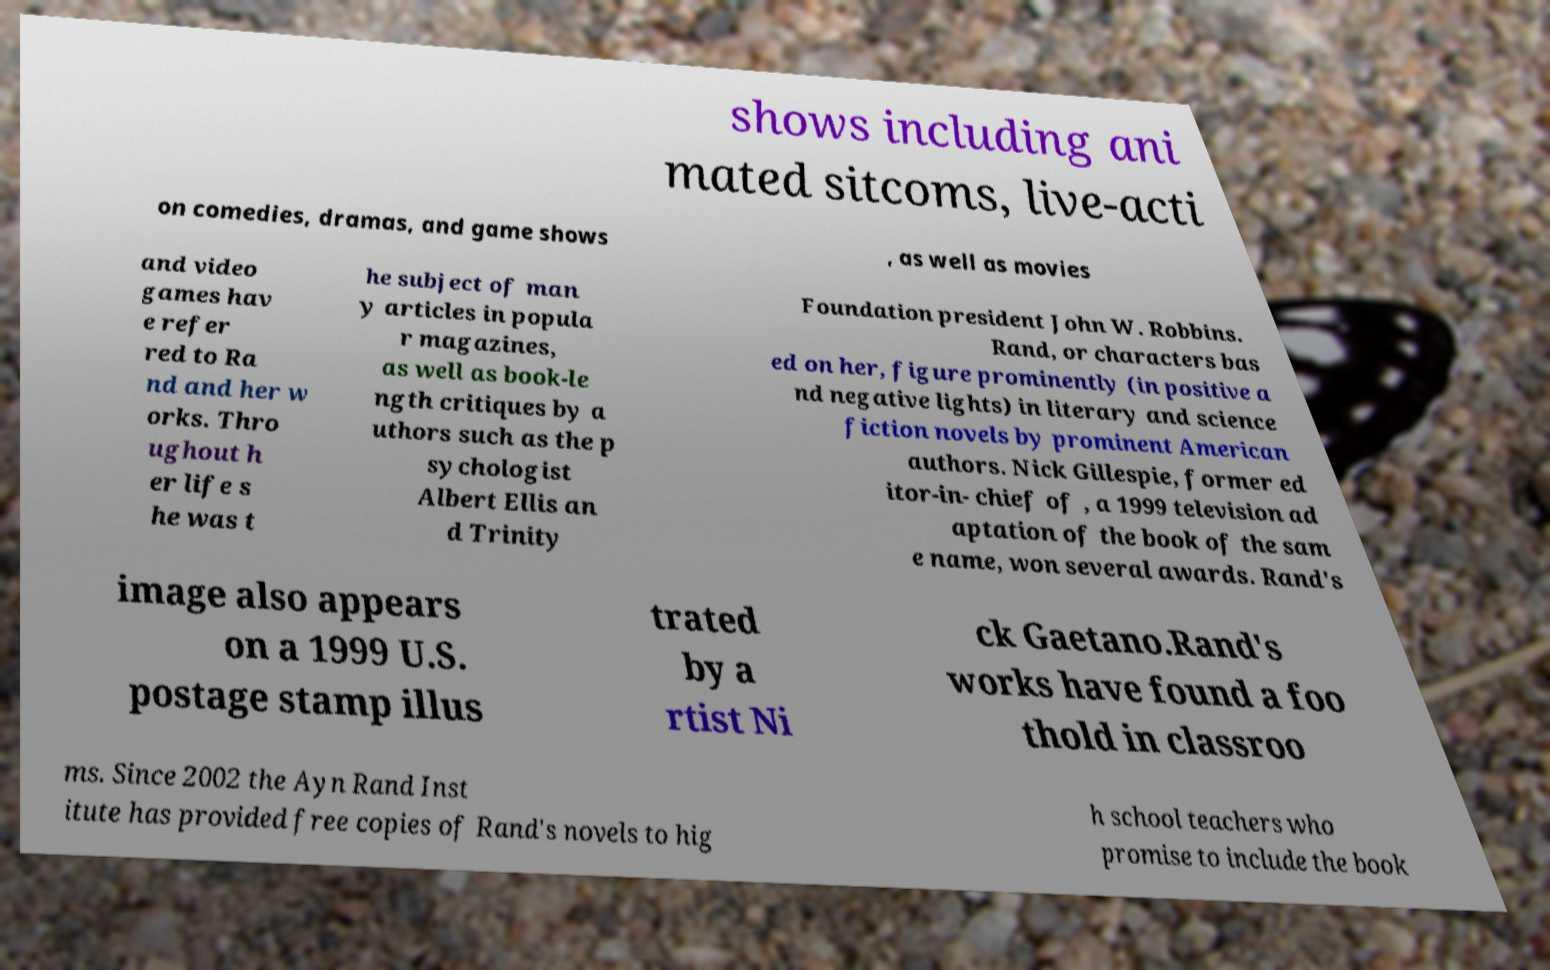For documentation purposes, I need the text within this image transcribed. Could you provide that? shows including ani mated sitcoms, live-acti on comedies, dramas, and game shows , as well as movies and video games hav e refer red to Ra nd and her w orks. Thro ughout h er life s he was t he subject of man y articles in popula r magazines, as well as book-le ngth critiques by a uthors such as the p sychologist Albert Ellis an d Trinity Foundation president John W. Robbins. Rand, or characters bas ed on her, figure prominently (in positive a nd negative lights) in literary and science fiction novels by prominent American authors. Nick Gillespie, former ed itor-in- chief of , a 1999 television ad aptation of the book of the sam e name, won several awards. Rand's image also appears on a 1999 U.S. postage stamp illus trated by a rtist Ni ck Gaetano.Rand's works have found a foo thold in classroo ms. Since 2002 the Ayn Rand Inst itute has provided free copies of Rand's novels to hig h school teachers who promise to include the book 